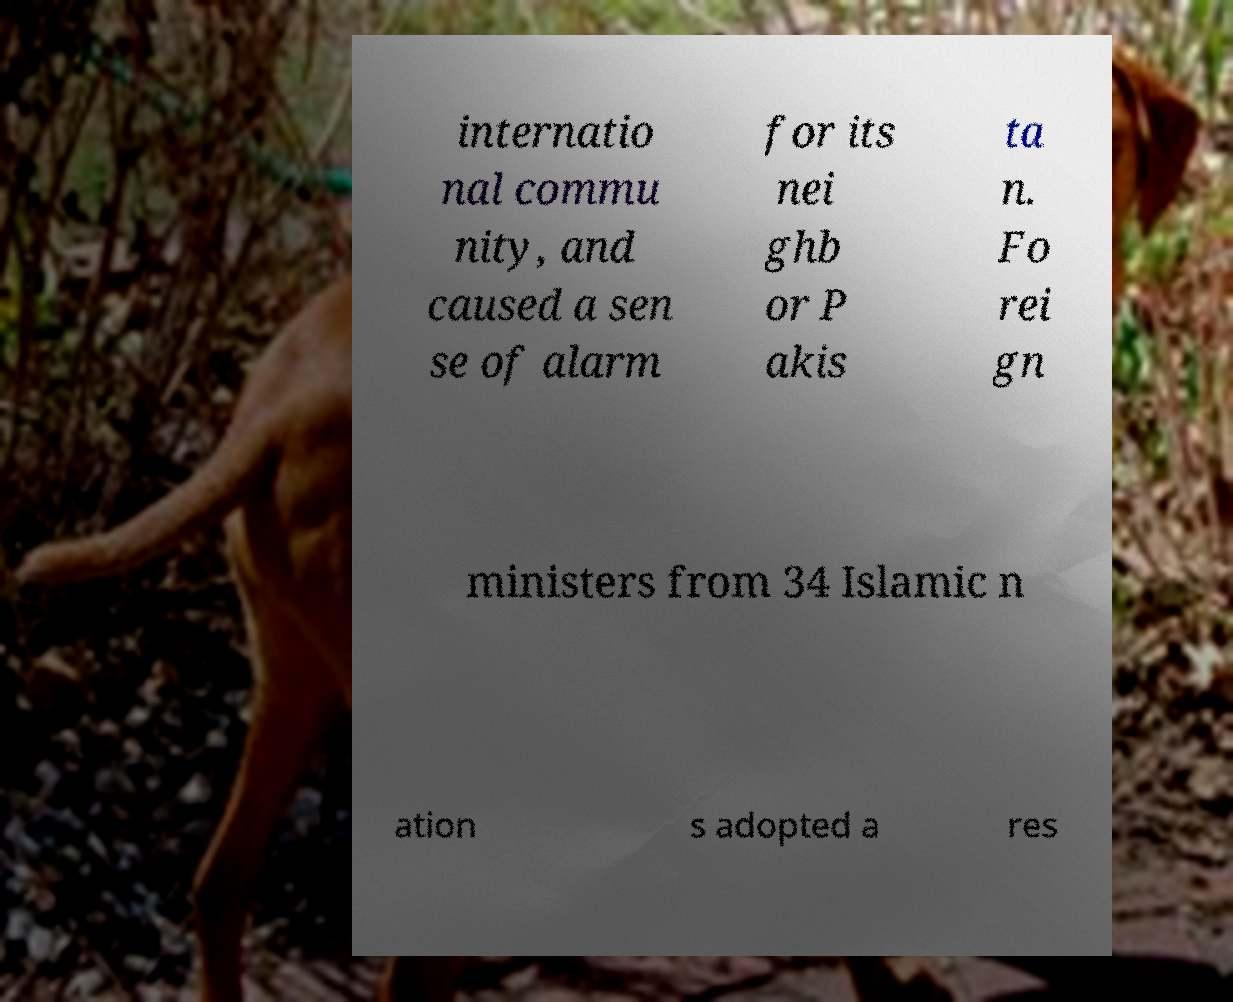Can you accurately transcribe the text from the provided image for me? internatio nal commu nity, and caused a sen se of alarm for its nei ghb or P akis ta n. Fo rei gn ministers from 34 Islamic n ation s adopted a res 